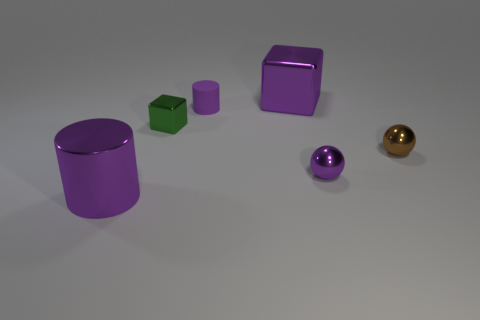What are the possible materials of these objects? The materials of the objects could be a matte plastic for the purple items, due to their uniform diffused reflection, and perhaps a metal for the golden sphere, suggested by its shinier appearance. 